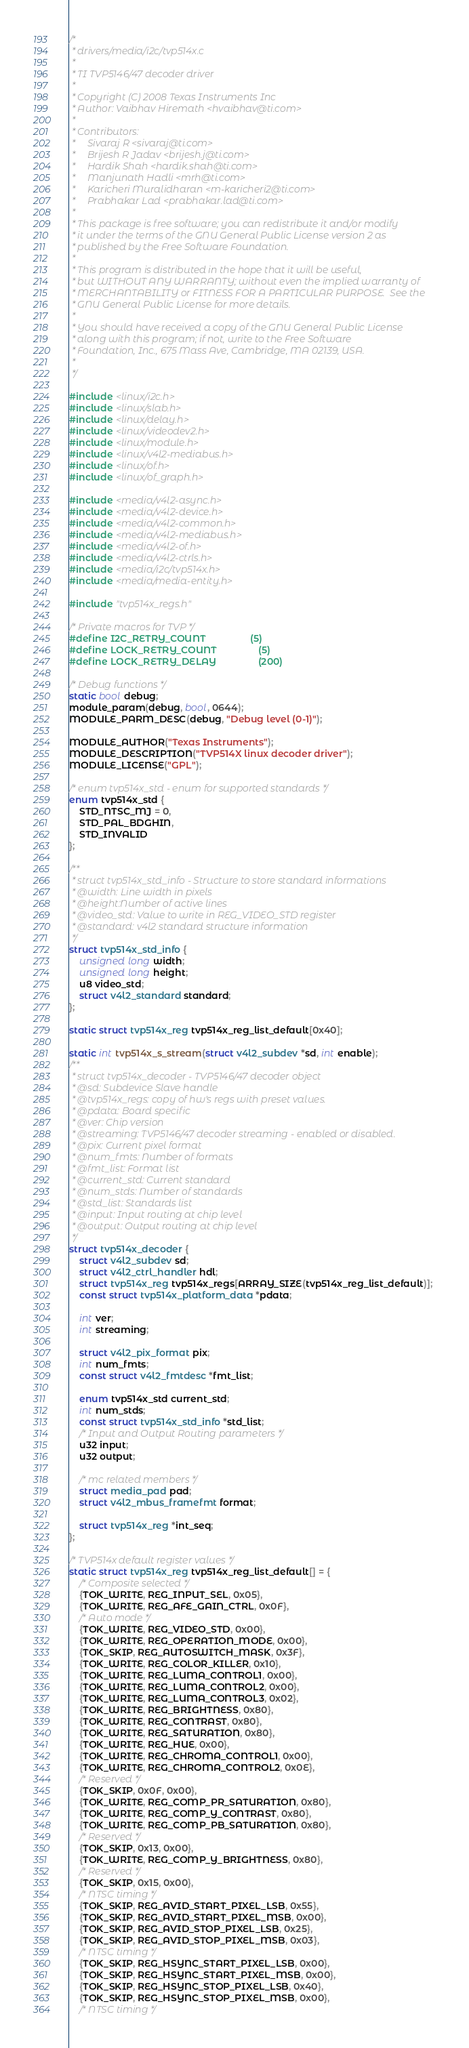Convert code to text. <code><loc_0><loc_0><loc_500><loc_500><_C_>/*
 * drivers/media/i2c/tvp514x.c
 *
 * TI TVP5146/47 decoder driver
 *
 * Copyright (C) 2008 Texas Instruments Inc
 * Author: Vaibhav Hiremath <hvaibhav@ti.com>
 *
 * Contributors:
 *     Sivaraj R <sivaraj@ti.com>
 *     Brijesh R Jadav <brijesh.j@ti.com>
 *     Hardik Shah <hardik.shah@ti.com>
 *     Manjunath Hadli <mrh@ti.com>
 *     Karicheri Muralidharan <m-karicheri2@ti.com>
 *     Prabhakar Lad <prabhakar.lad@ti.com>
 *
 * This package is free software; you can redistribute it and/or modify
 * it under the terms of the GNU General Public License version 2 as
 * published by the Free Software Foundation.
 *
 * This program is distributed in the hope that it will be useful,
 * but WITHOUT ANY WARRANTY; without even the implied warranty of
 * MERCHANTABILITY or FITNESS FOR A PARTICULAR PURPOSE.  See the
 * GNU General Public License for more details.
 *
 * You should have received a copy of the GNU General Public License
 * along with this program; if not, write to the Free Software
 * Foundation, Inc., 675 Mass Ave, Cambridge, MA 02139, USA.
 *
 */

#include <linux/i2c.h>
#include <linux/slab.h>
#include <linux/delay.h>
#include <linux/videodev2.h>
#include <linux/module.h>
#include <linux/v4l2-mediabus.h>
#include <linux/of.h>
#include <linux/of_graph.h>

#include <media/v4l2-async.h>
#include <media/v4l2-device.h>
#include <media/v4l2-common.h>
#include <media/v4l2-mediabus.h>
#include <media/v4l2-of.h>
#include <media/v4l2-ctrls.h>
#include <media/i2c/tvp514x.h>
#include <media/media-entity.h>

#include "tvp514x_regs.h"

/* Private macros for TVP */
#define I2C_RETRY_COUNT                 (5)
#define LOCK_RETRY_COUNT                (5)
#define LOCK_RETRY_DELAY                (200)

/* Debug functions */
static bool debug;
module_param(debug, bool, 0644);
MODULE_PARM_DESC(debug, "Debug level (0-1)");

MODULE_AUTHOR("Texas Instruments");
MODULE_DESCRIPTION("TVP514X linux decoder driver");
MODULE_LICENSE("GPL");

/* enum tvp514x_std - enum for supported standards */
enum tvp514x_std {
	STD_NTSC_MJ = 0,
	STD_PAL_BDGHIN,
	STD_INVALID
};

/**
 * struct tvp514x_std_info - Structure to store standard informations
 * @width: Line width in pixels
 * @height:Number of active lines
 * @video_std: Value to write in REG_VIDEO_STD register
 * @standard: v4l2 standard structure information
 */
struct tvp514x_std_info {
	unsigned long width;
	unsigned long height;
	u8 video_std;
	struct v4l2_standard standard;
};

static struct tvp514x_reg tvp514x_reg_list_default[0x40];

static int tvp514x_s_stream(struct v4l2_subdev *sd, int enable);
/**
 * struct tvp514x_decoder - TVP5146/47 decoder object
 * @sd: Subdevice Slave handle
 * @tvp514x_regs: copy of hw's regs with preset values.
 * @pdata: Board specific
 * @ver: Chip version
 * @streaming: TVP5146/47 decoder streaming - enabled or disabled.
 * @pix: Current pixel format
 * @num_fmts: Number of formats
 * @fmt_list: Format list
 * @current_std: Current standard
 * @num_stds: Number of standards
 * @std_list: Standards list
 * @input: Input routing at chip level
 * @output: Output routing at chip level
 */
struct tvp514x_decoder {
	struct v4l2_subdev sd;
	struct v4l2_ctrl_handler hdl;
	struct tvp514x_reg tvp514x_regs[ARRAY_SIZE(tvp514x_reg_list_default)];
	const struct tvp514x_platform_data *pdata;

	int ver;
	int streaming;

	struct v4l2_pix_format pix;
	int num_fmts;
	const struct v4l2_fmtdesc *fmt_list;

	enum tvp514x_std current_std;
	int num_stds;
	const struct tvp514x_std_info *std_list;
	/* Input and Output Routing parameters */
	u32 input;
	u32 output;

	/* mc related members */
	struct media_pad pad;
	struct v4l2_mbus_framefmt format;

	struct tvp514x_reg *int_seq;
};

/* TVP514x default register values */
static struct tvp514x_reg tvp514x_reg_list_default[] = {
	/* Composite selected */
	{TOK_WRITE, REG_INPUT_SEL, 0x05},
	{TOK_WRITE, REG_AFE_GAIN_CTRL, 0x0F},
	/* Auto mode */
	{TOK_WRITE, REG_VIDEO_STD, 0x00},
	{TOK_WRITE, REG_OPERATION_MODE, 0x00},
	{TOK_SKIP, REG_AUTOSWITCH_MASK, 0x3F},
	{TOK_WRITE, REG_COLOR_KILLER, 0x10},
	{TOK_WRITE, REG_LUMA_CONTROL1, 0x00},
	{TOK_WRITE, REG_LUMA_CONTROL2, 0x00},
	{TOK_WRITE, REG_LUMA_CONTROL3, 0x02},
	{TOK_WRITE, REG_BRIGHTNESS, 0x80},
	{TOK_WRITE, REG_CONTRAST, 0x80},
	{TOK_WRITE, REG_SATURATION, 0x80},
	{TOK_WRITE, REG_HUE, 0x00},
	{TOK_WRITE, REG_CHROMA_CONTROL1, 0x00},
	{TOK_WRITE, REG_CHROMA_CONTROL2, 0x0E},
	/* Reserved */
	{TOK_SKIP, 0x0F, 0x00},
	{TOK_WRITE, REG_COMP_PR_SATURATION, 0x80},
	{TOK_WRITE, REG_COMP_Y_CONTRAST, 0x80},
	{TOK_WRITE, REG_COMP_PB_SATURATION, 0x80},
	/* Reserved */
	{TOK_SKIP, 0x13, 0x00},
	{TOK_WRITE, REG_COMP_Y_BRIGHTNESS, 0x80},
	/* Reserved */
	{TOK_SKIP, 0x15, 0x00},
	/* NTSC timing */
	{TOK_SKIP, REG_AVID_START_PIXEL_LSB, 0x55},
	{TOK_SKIP, REG_AVID_START_PIXEL_MSB, 0x00},
	{TOK_SKIP, REG_AVID_STOP_PIXEL_LSB, 0x25},
	{TOK_SKIP, REG_AVID_STOP_PIXEL_MSB, 0x03},
	/* NTSC timing */
	{TOK_SKIP, REG_HSYNC_START_PIXEL_LSB, 0x00},
	{TOK_SKIP, REG_HSYNC_START_PIXEL_MSB, 0x00},
	{TOK_SKIP, REG_HSYNC_STOP_PIXEL_LSB, 0x40},
	{TOK_SKIP, REG_HSYNC_STOP_PIXEL_MSB, 0x00},
	/* NTSC timing */</code> 